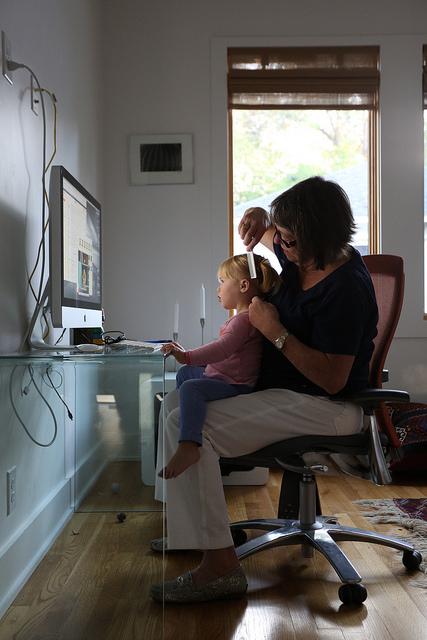Where is the monitor?
Keep it brief. Left. Does this look like a professional barber shop?
Answer briefly. No. Is that at nighttime?
Quick response, please. No. 